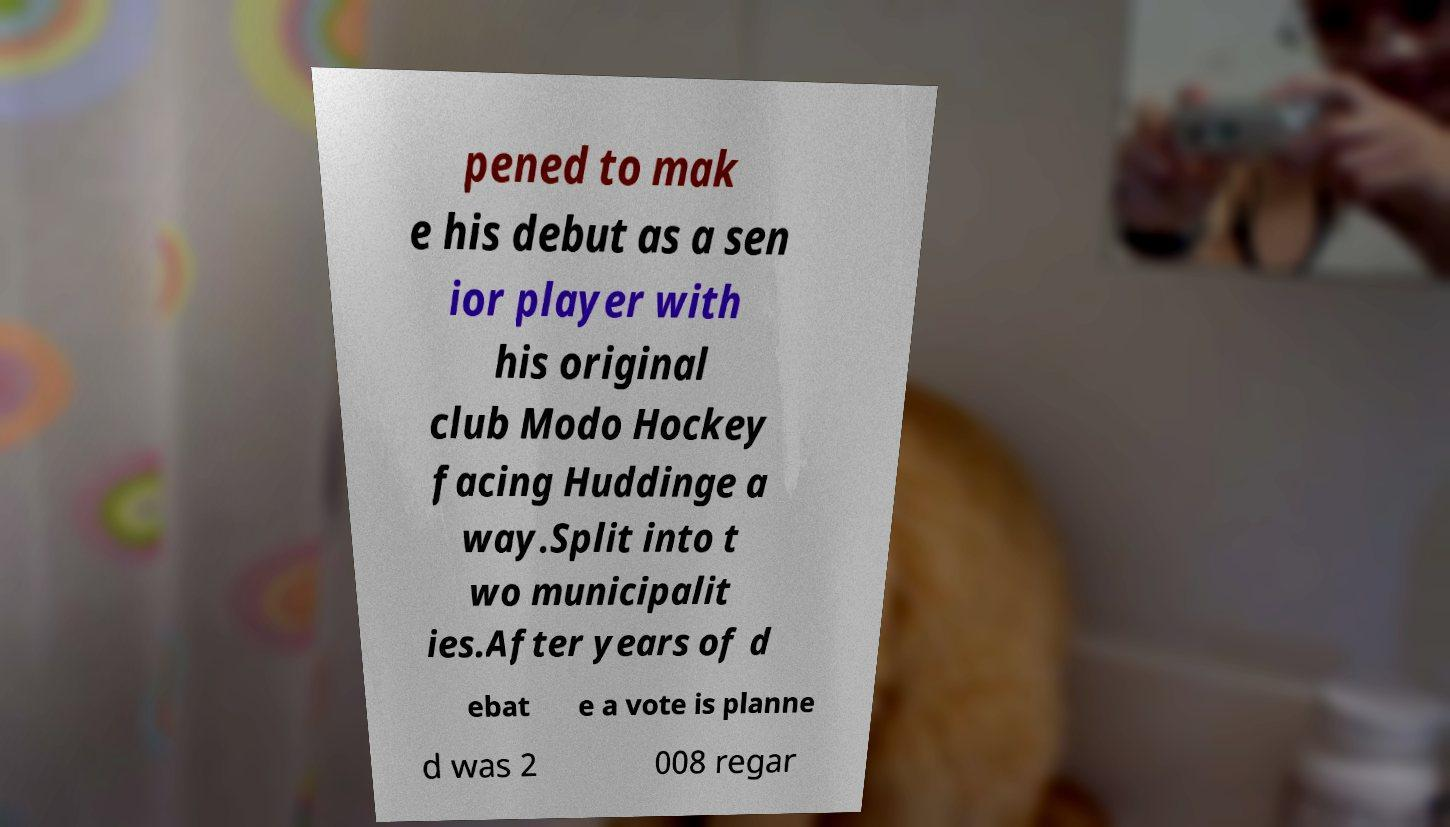For documentation purposes, I need the text within this image transcribed. Could you provide that? pened to mak e his debut as a sen ior player with his original club Modo Hockey facing Huddinge a way.Split into t wo municipalit ies.After years of d ebat e a vote is planne d was 2 008 regar 